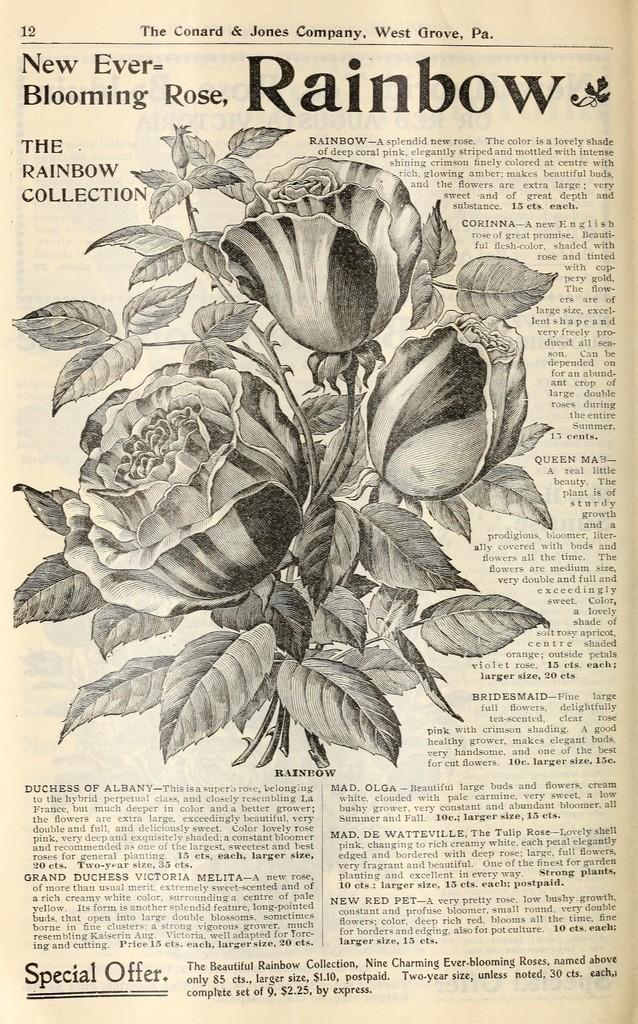Describe this image in one or two sentences. In this image we can see a paper. On the paper we can see picture of flowers and leaves. There is text written on it. 